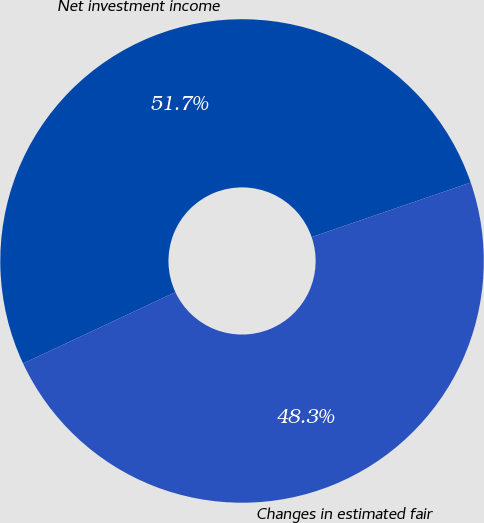Convert chart to OTSL. <chart><loc_0><loc_0><loc_500><loc_500><pie_chart><fcel>Net investment income<fcel>Changes in estimated fair<nl><fcel>51.71%<fcel>48.29%<nl></chart> 